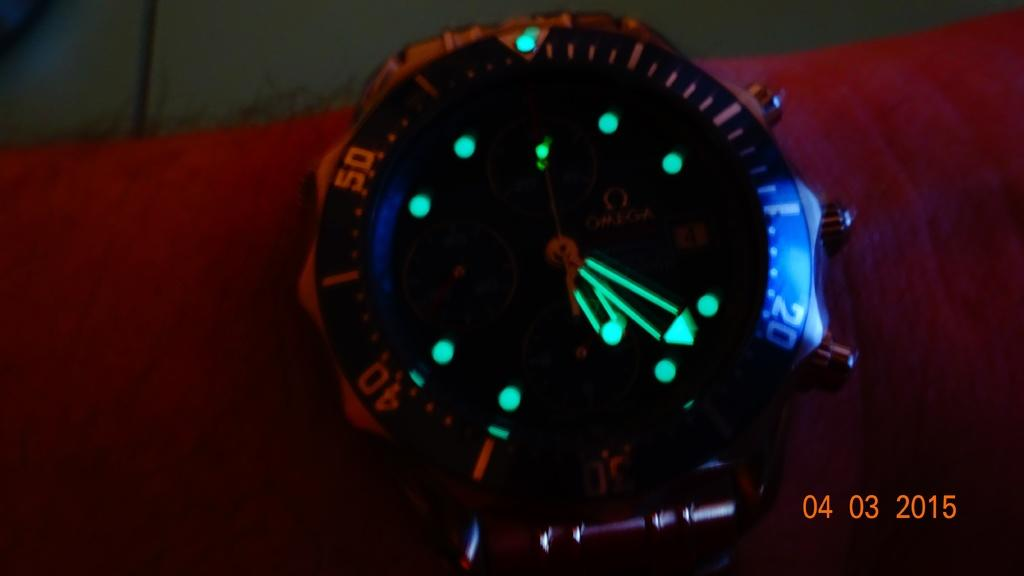<image>
Describe the image concisely. Even thought is dark, the number 20 stands out on the dial of the watch. 